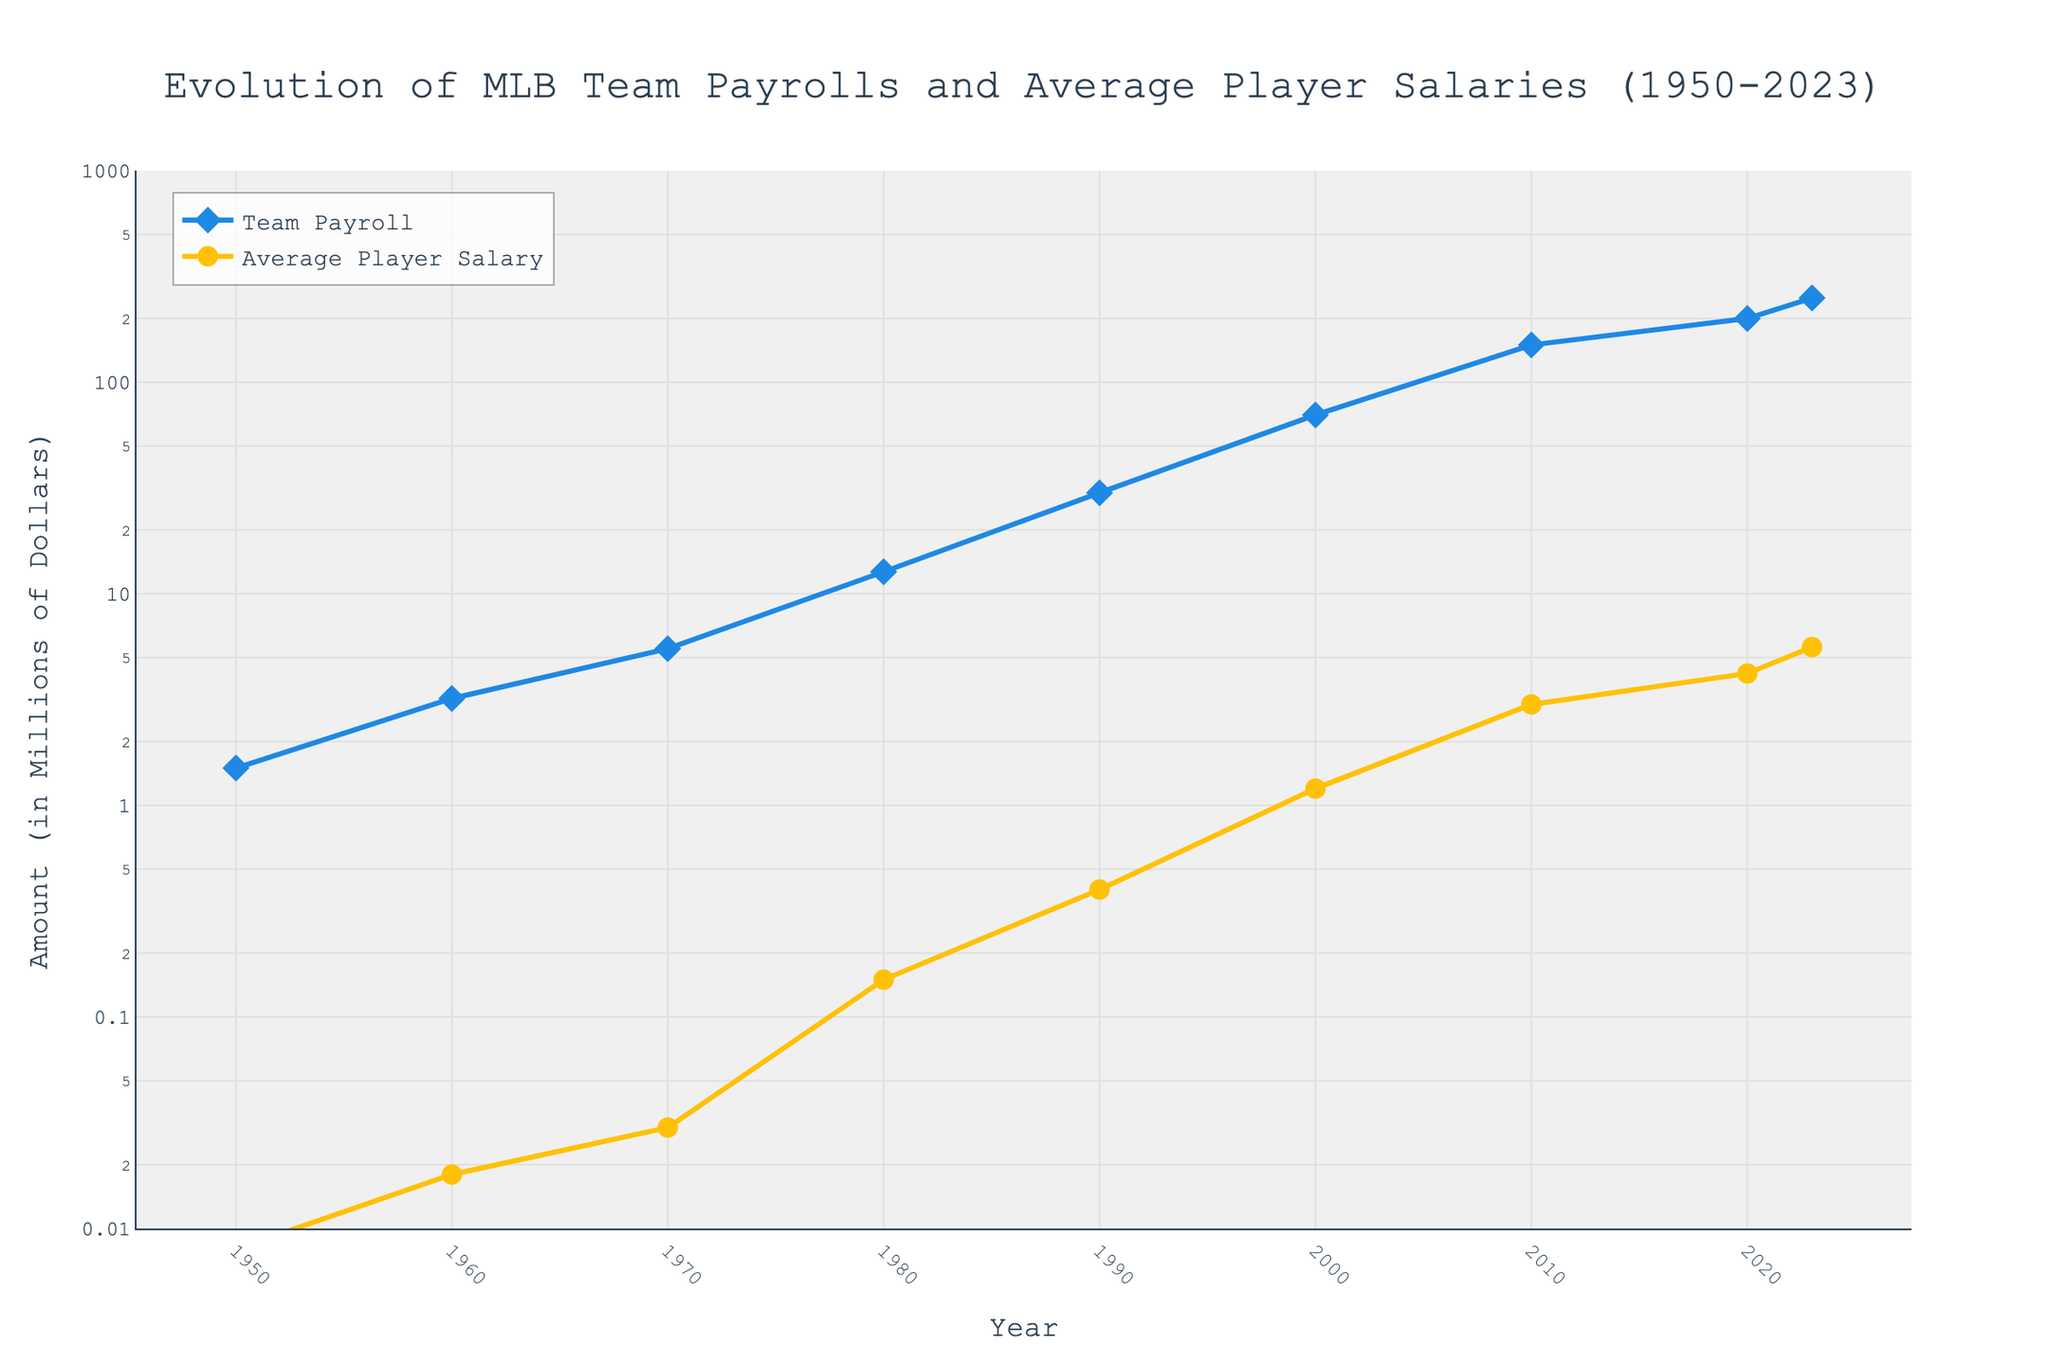What's the title of the figure? The title of the figure is explicitly stated at the top of the image in a large font.
Answer: Evolution of MLB Team Payrolls and Average Player Salaries (1950-2023) How many data points are shown on the plot? By counting the markers on each line, we see there are data points plotted for the years: 1950, 1960, 1970, 1980, 1990, 2000, 2010, 2020, and 2023.
Answer: 9 In which year does the average player salary reach $1 million? The yellow line representing the average player salary can be followed to identify the year where it breaks the $1 million mark. This occurs between 1990 and 2000.
Answer: 2000 What are the x-axis and y-axis titles? The titles of the axes are explicitly stated next to each axis. The x-axis is labeled "Year" and the y-axis is labeled "Amount (in Millions of Dollars)".
Answer: Year (x-axis), Amount (in Millions of Dollars) (y-axis) What's the difference in team payroll between 1990 and 2020? Observe the values at the markers for 1990 and 2020 for the blue line. In 1990, the team payroll is $30 million, and in 2020, it is $200 million. Subtract 30 from 200 to find the difference.
Answer: $170 million How does the growth rate of team payrolls compare to average player salaries over the entire period? Both lines show exponential growth, indicated by the log scale. To compare visually, the slope of both lines should be considered, with both showing similar upward trends but different starting points.
Answer: Both grow exponentially Which period shows the steepest increase in average player salaries? Scan the yellow line that represents average player salaries and look for the period where the line is the steepest. The steepest increase is from 1980 to 2000.
Answer: 1980-2000 What's the average player salary in 2010 compared to 1970? Compare the yellow markers for the years 2010 and 1970. In 1970, the salary is $30,000 (converted to $0.03 million), and in 2010, it's $3 million. The comparison shows an enormous increase.
Answer: $3 million in 2010 vs. $0.03 million in 1970 Is team payroll growth constant over the years? Examine the intervals of the blue line; it indicates exponential growth rather than a constant linear increase due to the log scale on the y-axis.
Answer: Exponential growth How does the change in team payroll from 2000 to 2020 compare to that from 1950 to 1970? From 2000 to 2020, team payroll goes from $70 million to $200 million, showing an increase of $130 million. From 1950 to 1970, it increases from $1.5 million to $5.5 million, showing an increase of $4 million. This contrast indicates a much steeper increase in the later period.
Answer: $130 million vs. $4 million 